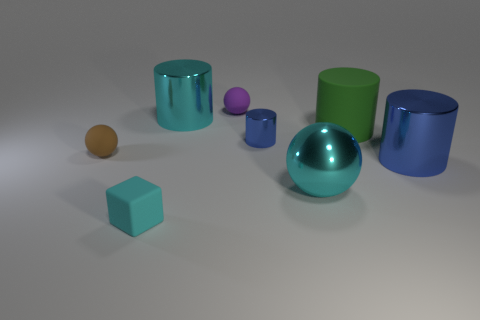Can you tell me what the largest object in the image is? The largest object in the image appears to be the shiny green cylinder towards the center. It has a significant presence due to its size compared to the other objects in the scene. 